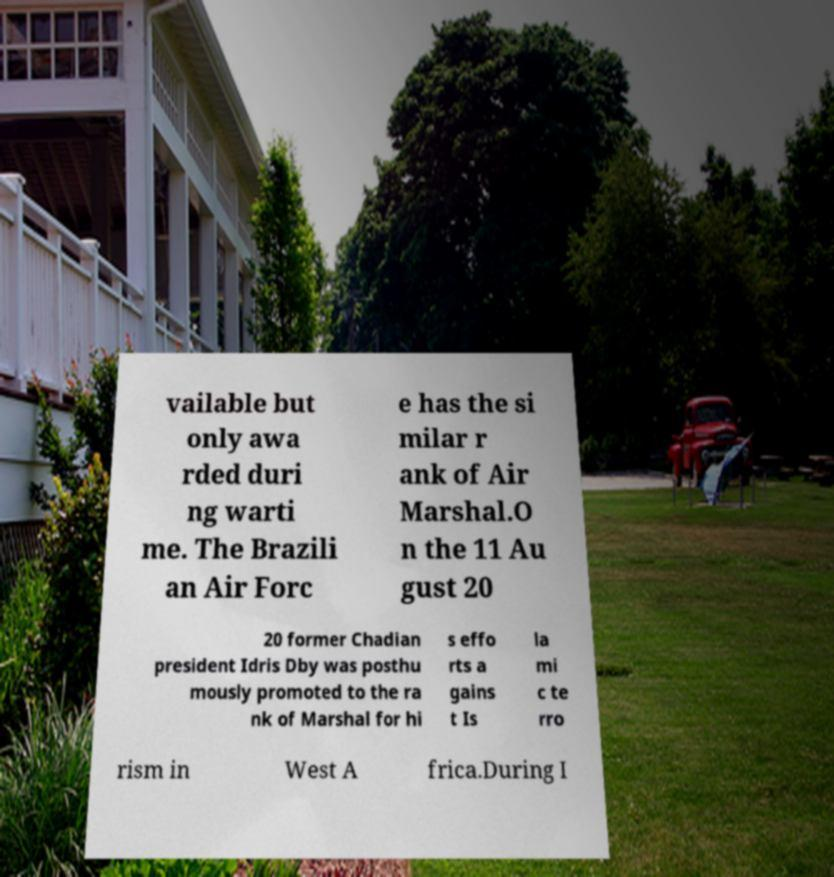Could you assist in decoding the text presented in this image and type it out clearly? vailable but only awa rded duri ng warti me. The Brazili an Air Forc e has the si milar r ank of Air Marshal.O n the 11 Au gust 20 20 former Chadian president Idris Dby was posthu mously promoted to the ra nk of Marshal for hi s effo rts a gains t Is la mi c te rro rism in West A frica.During I 